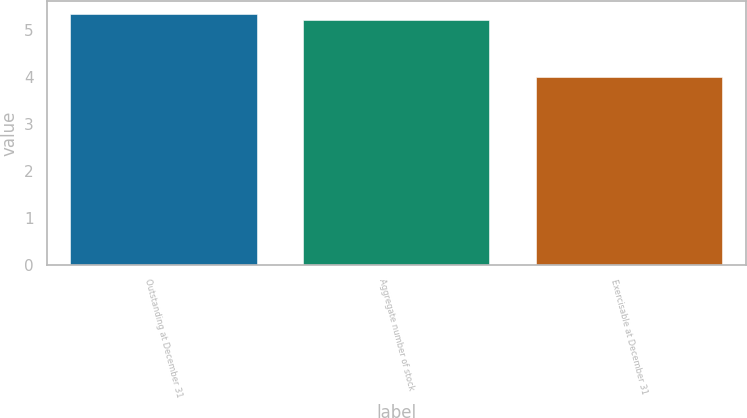Convert chart. <chart><loc_0><loc_0><loc_500><loc_500><bar_chart><fcel>Outstanding at December 31<fcel>Aggregate number of stock<fcel>Exercisable at December 31<nl><fcel>5.34<fcel>5.21<fcel>4<nl></chart> 